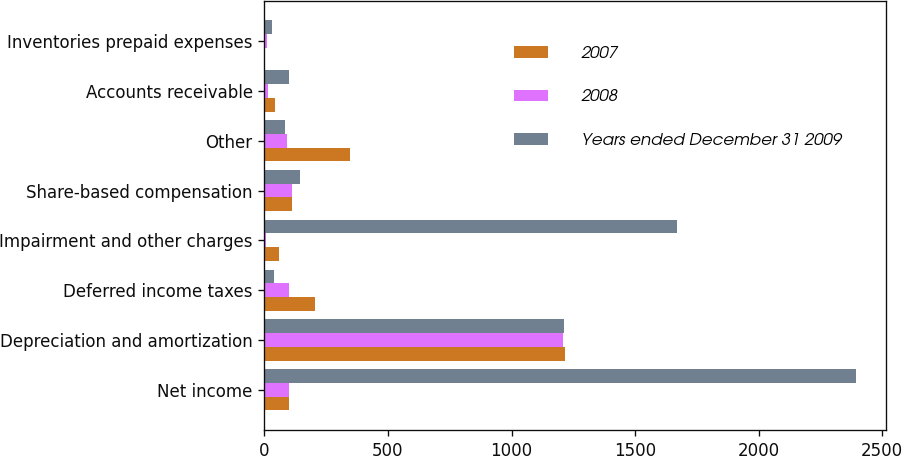<chart> <loc_0><loc_0><loc_500><loc_500><stacked_bar_chart><ecel><fcel>Net income<fcel>Depreciation and amortization<fcel>Deferred income taxes<fcel>Impairment and other charges<fcel>Share-based compensation<fcel>Other<fcel>Accounts receivable<fcel>Inventories prepaid expenses<nl><fcel>2007<fcel>100.85<fcel>1216.2<fcel>203<fcel>61.1<fcel>112.9<fcel>347.1<fcel>42<fcel>1<nl><fcel>2008<fcel>100.85<fcel>1207.8<fcel>101.5<fcel>6<fcel>112.5<fcel>90.5<fcel>16.1<fcel>11<nl><fcel>Years ended December 31 2009<fcel>2395.1<fcel>1214.1<fcel>39.1<fcel>1670.3<fcel>142.4<fcel>85.3<fcel>100.2<fcel>29.6<nl></chart> 